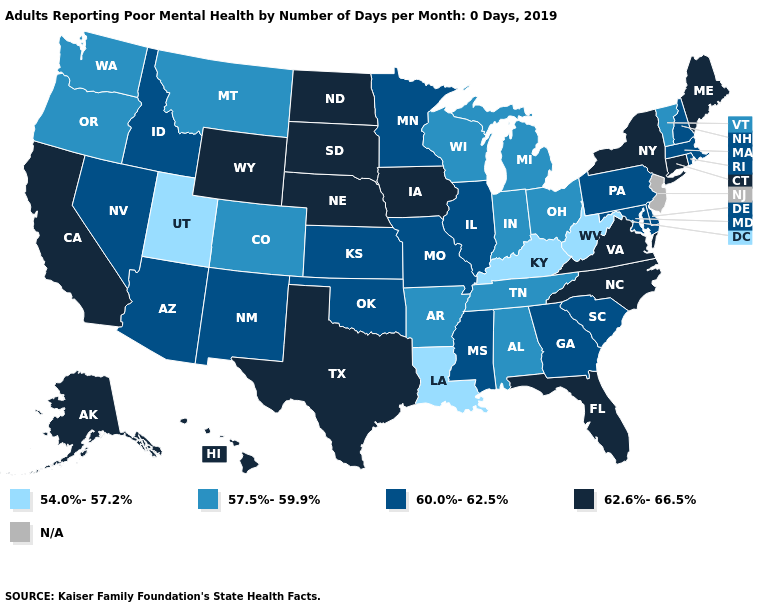What is the value of Oklahoma?
Give a very brief answer. 60.0%-62.5%. Which states have the highest value in the USA?
Quick response, please. Alaska, California, Connecticut, Florida, Hawaii, Iowa, Maine, Nebraska, New York, North Carolina, North Dakota, South Dakota, Texas, Virginia, Wyoming. What is the lowest value in the USA?
Quick response, please. 54.0%-57.2%. Does Nebraska have the highest value in the USA?
Write a very short answer. Yes. Name the states that have a value in the range N/A?
Give a very brief answer. New Jersey. Which states have the lowest value in the South?
Write a very short answer. Kentucky, Louisiana, West Virginia. Name the states that have a value in the range 62.6%-66.5%?
Short answer required. Alaska, California, Connecticut, Florida, Hawaii, Iowa, Maine, Nebraska, New York, North Carolina, North Dakota, South Dakota, Texas, Virginia, Wyoming. What is the lowest value in the South?
Concise answer only. 54.0%-57.2%. What is the value of Delaware?
Keep it brief. 60.0%-62.5%. Among the states that border Wyoming , which have the highest value?
Short answer required. Nebraska, South Dakota. Which states have the lowest value in the West?
Write a very short answer. Utah. Does Kentucky have the lowest value in the USA?
Write a very short answer. Yes. Among the states that border Florida , which have the lowest value?
Quick response, please. Alabama. What is the lowest value in states that border Nebraska?
Give a very brief answer. 57.5%-59.9%. Which states have the highest value in the USA?
Keep it brief. Alaska, California, Connecticut, Florida, Hawaii, Iowa, Maine, Nebraska, New York, North Carolina, North Dakota, South Dakota, Texas, Virginia, Wyoming. 